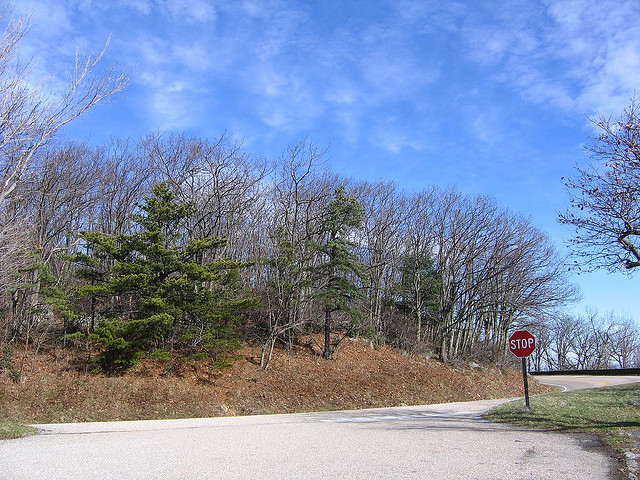What kind of clouds are in the picture? The sky shows cumulus clouds, which are fluffy and white, indicative of pleasant weather. 